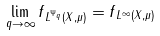Convert formula to latex. <formula><loc_0><loc_0><loc_500><loc_500>\lim _ { q \rightarrow \infty } \| f \| _ { L ^ { \Psi _ { q } } ( X , \mu ) } = \| f \| _ { L ^ { \infty } ( X , \mu ) }</formula> 